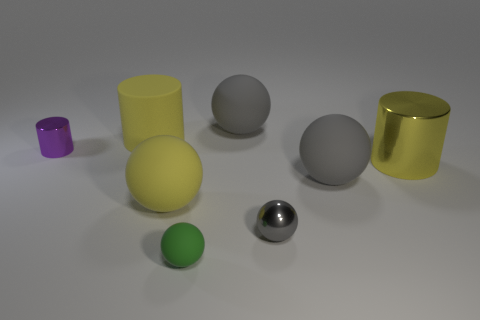Subtract all yellow cylinders. How many gray spheres are left? 3 Subtract all yellow spheres. How many spheres are left? 4 Subtract all green balls. How many balls are left? 4 Subtract all brown spheres. Subtract all yellow cylinders. How many spheres are left? 5 Add 1 large green rubber cylinders. How many objects exist? 9 Subtract all cylinders. How many objects are left? 5 Subtract all green matte balls. Subtract all gray rubber spheres. How many objects are left? 5 Add 7 small gray objects. How many small gray objects are left? 8 Add 6 big purple metallic objects. How many big purple metallic objects exist? 6 Subtract 0 green cylinders. How many objects are left? 8 